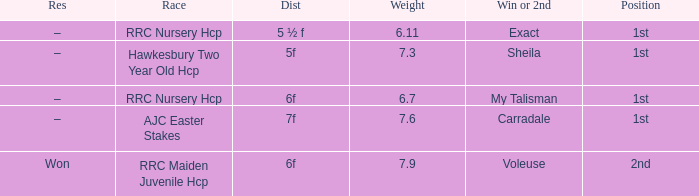What is the largest weight wth a Result of –, and a Distance of 7f? 7.6. 